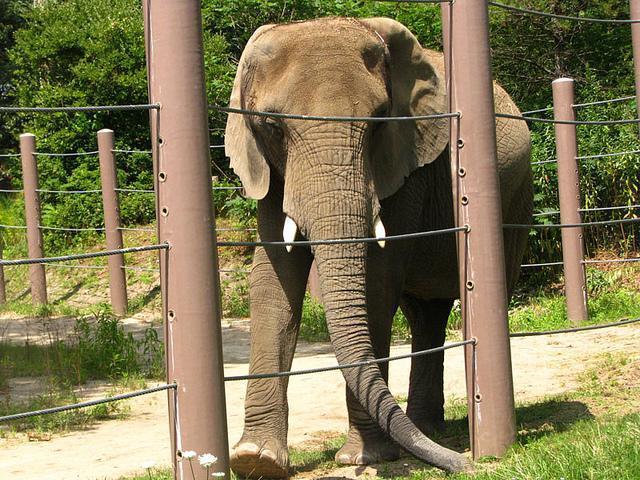How many legs can be seen?
Give a very brief answer. 3. How many poles in front of the elephant?
Give a very brief answer. 2. How many elephants can be seen?
Give a very brief answer. 1. How many train tracks are there?
Give a very brief answer. 0. 